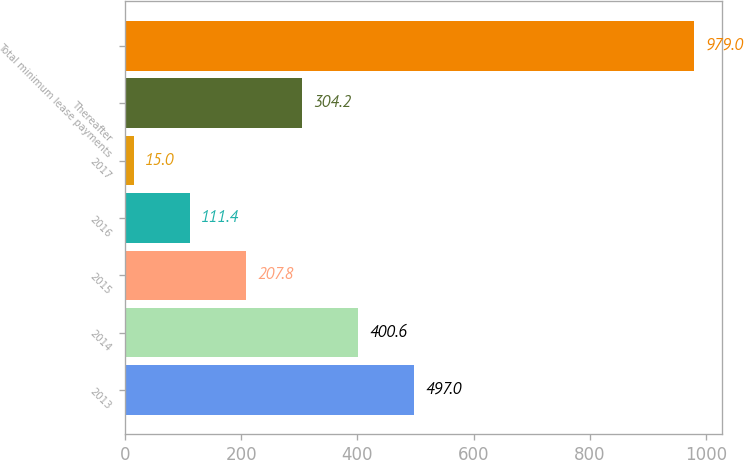Convert chart to OTSL. <chart><loc_0><loc_0><loc_500><loc_500><bar_chart><fcel>2013<fcel>2014<fcel>2015<fcel>2016<fcel>2017<fcel>Thereafter<fcel>Total minimum lease payments<nl><fcel>497<fcel>400.6<fcel>207.8<fcel>111.4<fcel>15<fcel>304.2<fcel>979<nl></chart> 